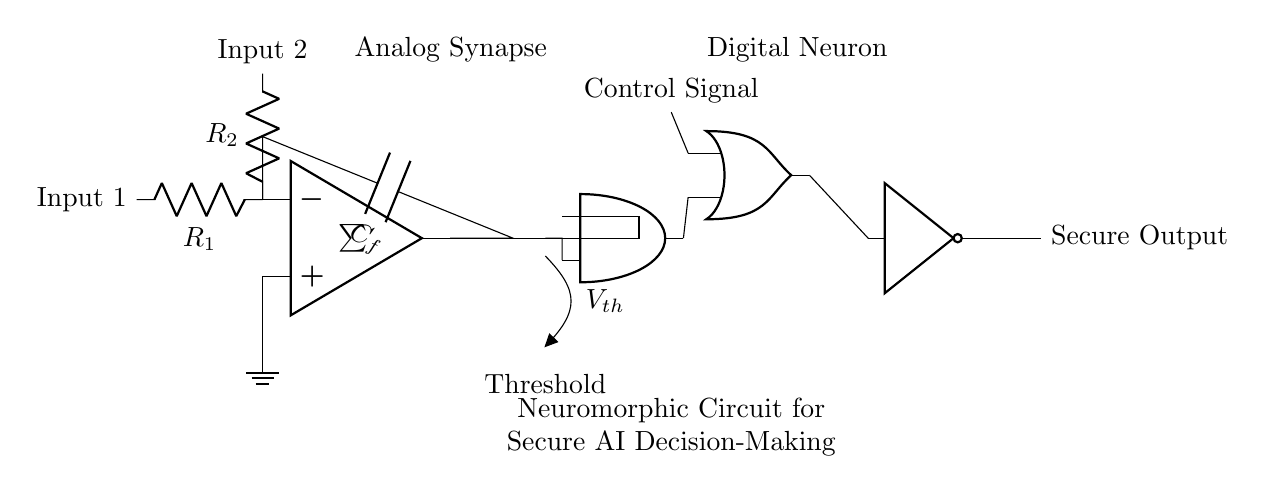What type of synapse is represented in the circuit? The circuit contains an analog synapse as indicated by the op amp symbol and surrounding components, such as resistors and a capacitor.
Answer: Analog synapse What components are used to create the analog synapse? The analog synapse is created using an operational amplifier, two resistors (R1 and R2), and a capacitor (C_f), which provide the necessary connections and functions.
Answer: Operational amplifier, resistors, capacitor How many digital logic gates are present in the digital neuron section? There are three digital logic gates: one AND gate, one OR gate, and one NOT gate. Each gate serves its purpose within the circuit for processing the signals.
Answer: Three What is the purpose of the threshold voltage, V_th, in the circuit? The threshold voltage, V_th, is used to decide when the input from the analog synapse is sufficient to activate the AND gate, thus aiding in secure decision-making for the AI system.
Answer: Decision criteria Which component provides the final output of the circuit? The final output of the circuit is provided by the NOT gate, which processes the signal from the OR gate and ensures the output is inverted before reaching the secure output.
Answer: NOT gate What is the label for the output of the entire neuromorphic circuit? The label for the output is "Secure Output," indicating that the output signal has undergone processing relevant to secure communication in AI decision-making systems.
Answer: Secure Output What function does the capacitor, C_f, perform in the analog synapse? The capacitor C_f integrates the input signal over time, helping to smooth out the output and serve as a form of memory in the synaptic operation.
Answer: Integrator, memory 